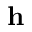Convert formula to latex. <formula><loc_0><loc_0><loc_500><loc_500>h</formula> 